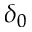Convert formula to latex. <formula><loc_0><loc_0><loc_500><loc_500>\delta _ { 0 }</formula> 